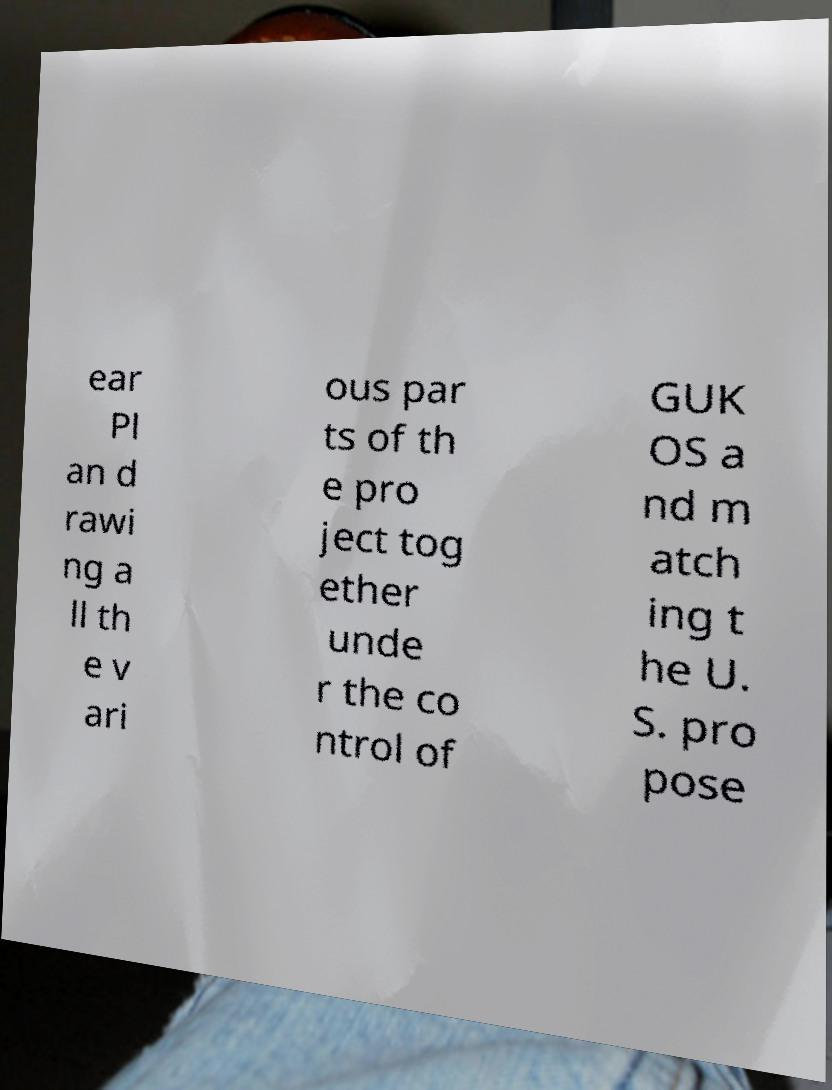For documentation purposes, I need the text within this image transcribed. Could you provide that? ear Pl an d rawi ng a ll th e v ari ous par ts of th e pro ject tog ether unde r the co ntrol of GUK OS a nd m atch ing t he U. S. pro pose 